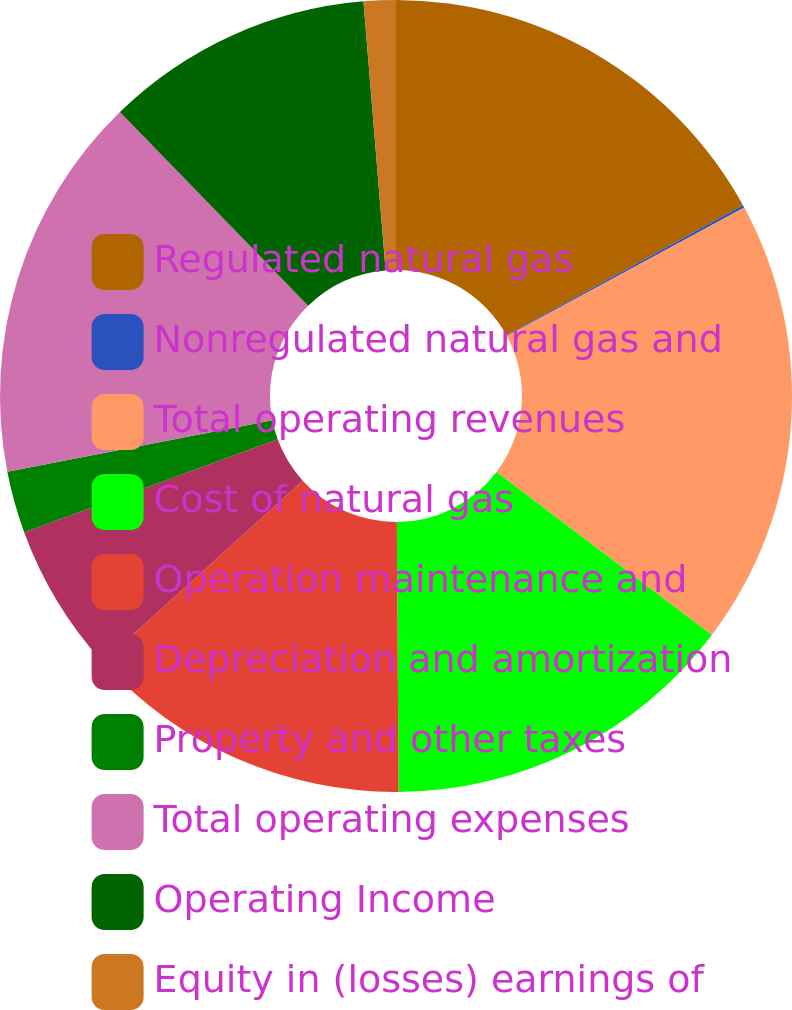Convert chart. <chart><loc_0><loc_0><loc_500><loc_500><pie_chart><fcel>Regulated natural gas<fcel>Nonregulated natural gas and<fcel>Total operating revenues<fcel>Cost of natural gas<fcel>Operation maintenance and<fcel>Depreciation and amortization<fcel>Property and other taxes<fcel>Total operating expenses<fcel>Operating Income<fcel>Equity in (losses) earnings of<nl><fcel>17.0%<fcel>0.11%<fcel>18.2%<fcel>14.59%<fcel>13.38%<fcel>6.14%<fcel>2.52%<fcel>15.79%<fcel>10.97%<fcel>1.31%<nl></chart> 